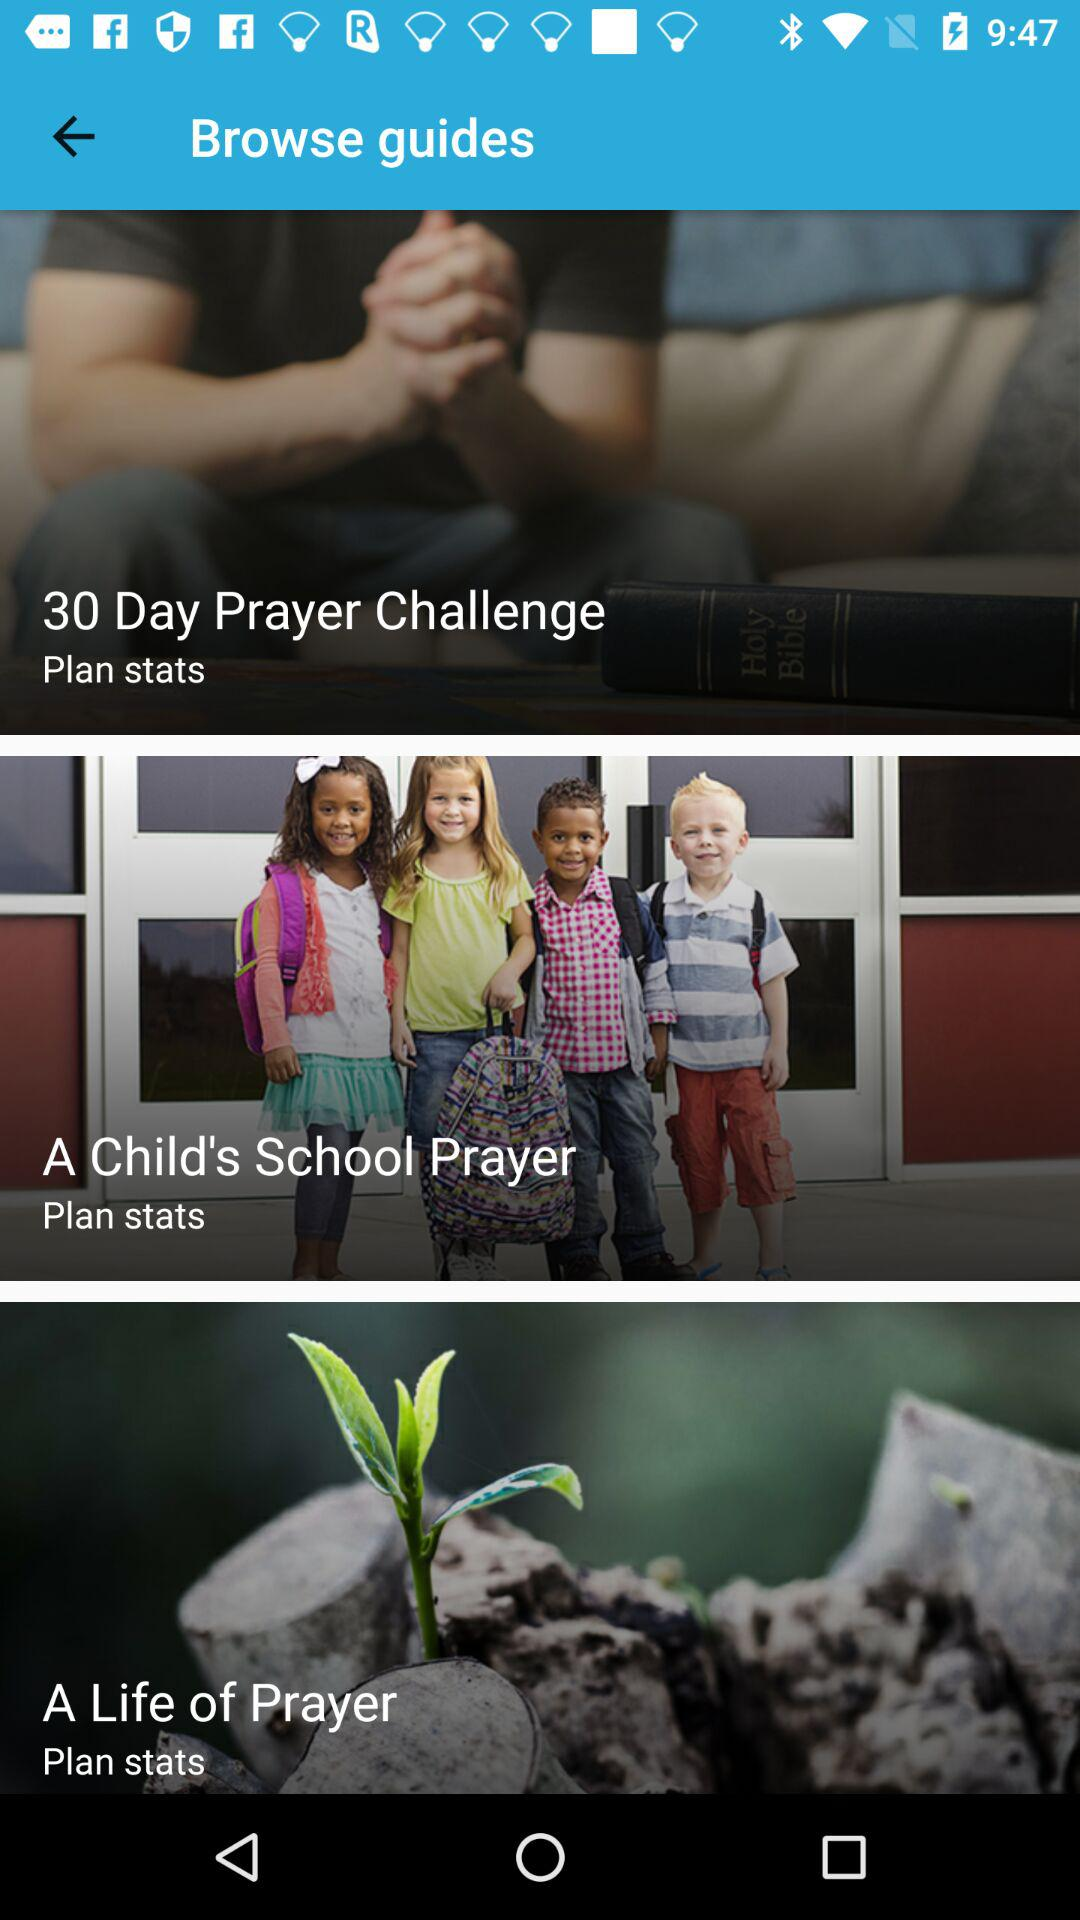For how many days is the prayer challenge? The prayer challenge is for 30 days. 